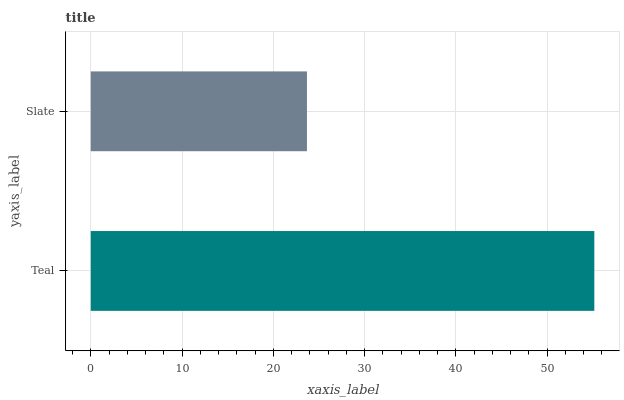Is Slate the minimum?
Answer yes or no. Yes. Is Teal the maximum?
Answer yes or no. Yes. Is Slate the maximum?
Answer yes or no. No. Is Teal greater than Slate?
Answer yes or no. Yes. Is Slate less than Teal?
Answer yes or no. Yes. Is Slate greater than Teal?
Answer yes or no. No. Is Teal less than Slate?
Answer yes or no. No. Is Teal the high median?
Answer yes or no. Yes. Is Slate the low median?
Answer yes or no. Yes. Is Slate the high median?
Answer yes or no. No. Is Teal the low median?
Answer yes or no. No. 